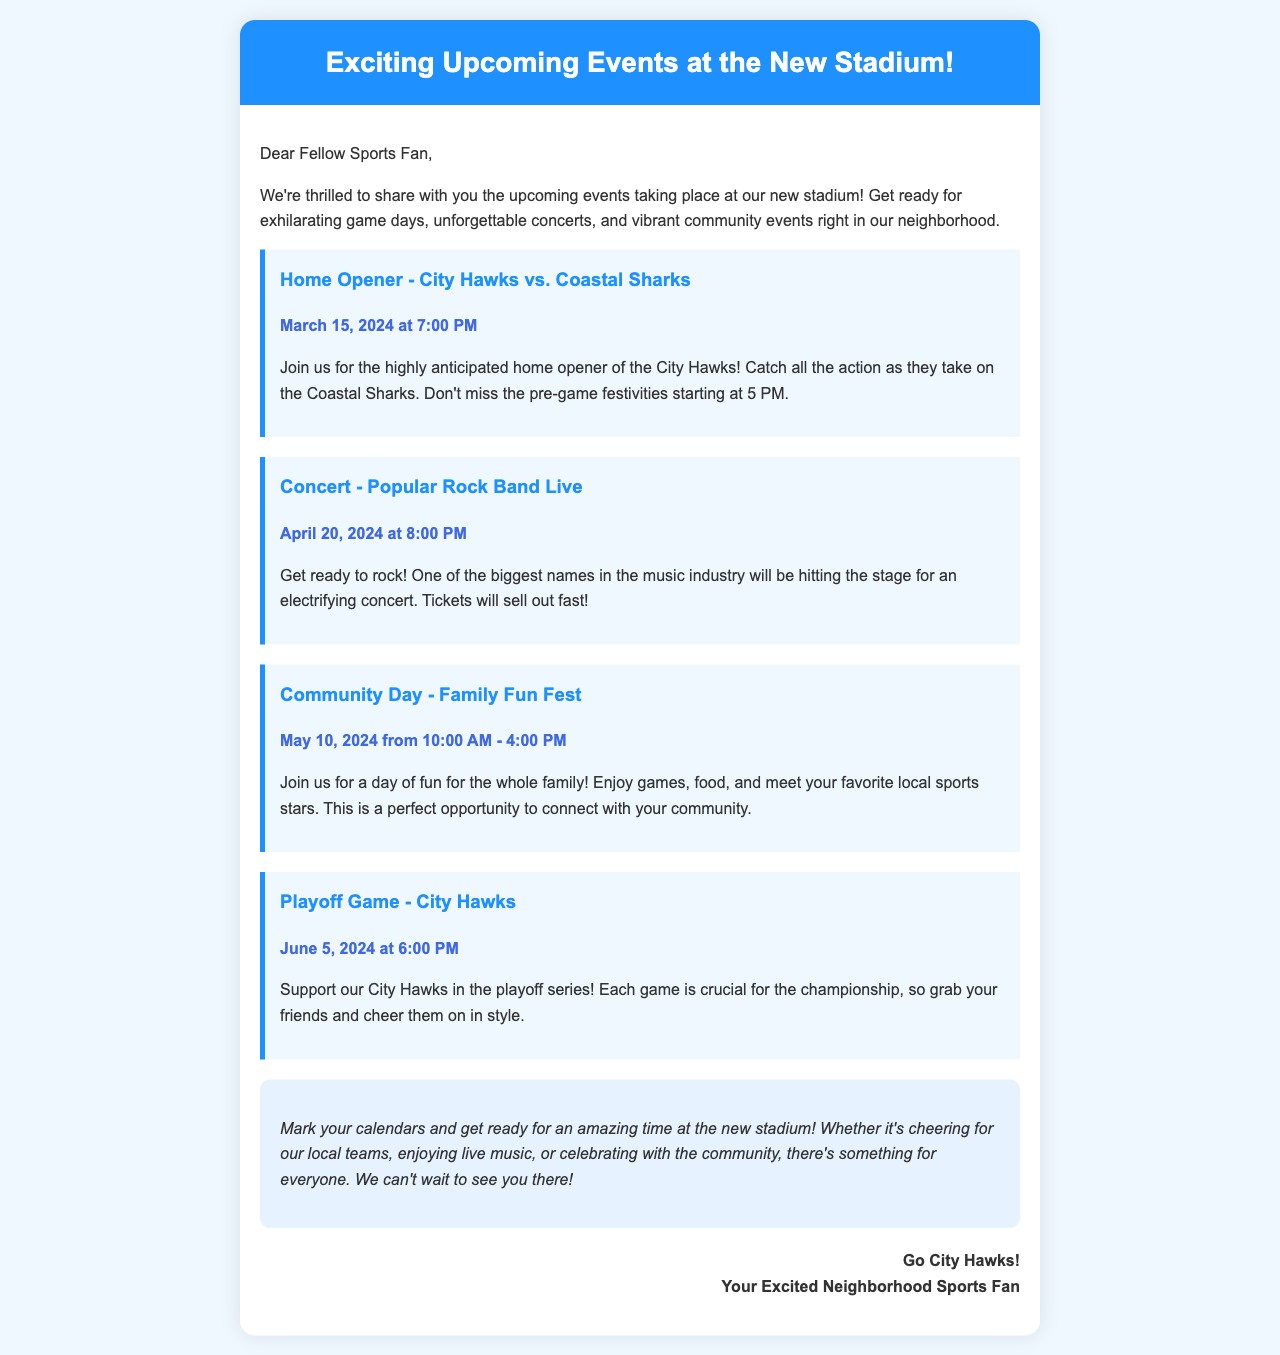What is the date of the home opener? The home opener is scheduled for March 15, 2024, which is mentioned as the date for the City Hawks vs. Coastal Sharks game.
Answer: March 15, 2024 What time does the concert start? The concert by the popular rock band starts at 8:00 PM on April 20, 2024, as indicated in the event details.
Answer: 8:00 PM What event is scheduled for May 10, 2024? The document lists "Community Day - Family Fun Fest" as the event taking place on that date from 10:00 AM to 4:00 PM.
Answer: Community Day - Family Fun Fest Who is playing in the playoff game? The playoff game features the City Hawks, as specifically mentioned in the document under the playoff game event section.
Answer: City Hawks What is the main feature of the Community Day event? The description highlights that Community Day will include family fun activities, food, and a chance to meet local sports stars.
Answer: Family Fun Fest How many events are listed in the document? There are four distinct events outlined in the schedule of the document, including the home opener, concert, community day, and playoff game.
Answer: Four Why should fans mark their calendars? The document emphasizes the excitement and variety of events, encouraging fans to mark their calendars for game days, concerts, and community events.
Answer: Excitement and variety of events When do pre-game festivities start on the home opener day? The document mentions that pre-game festivities for the home opener will begin at 5 PM, prior to the game at 7 PM.
Answer: 5 PM 